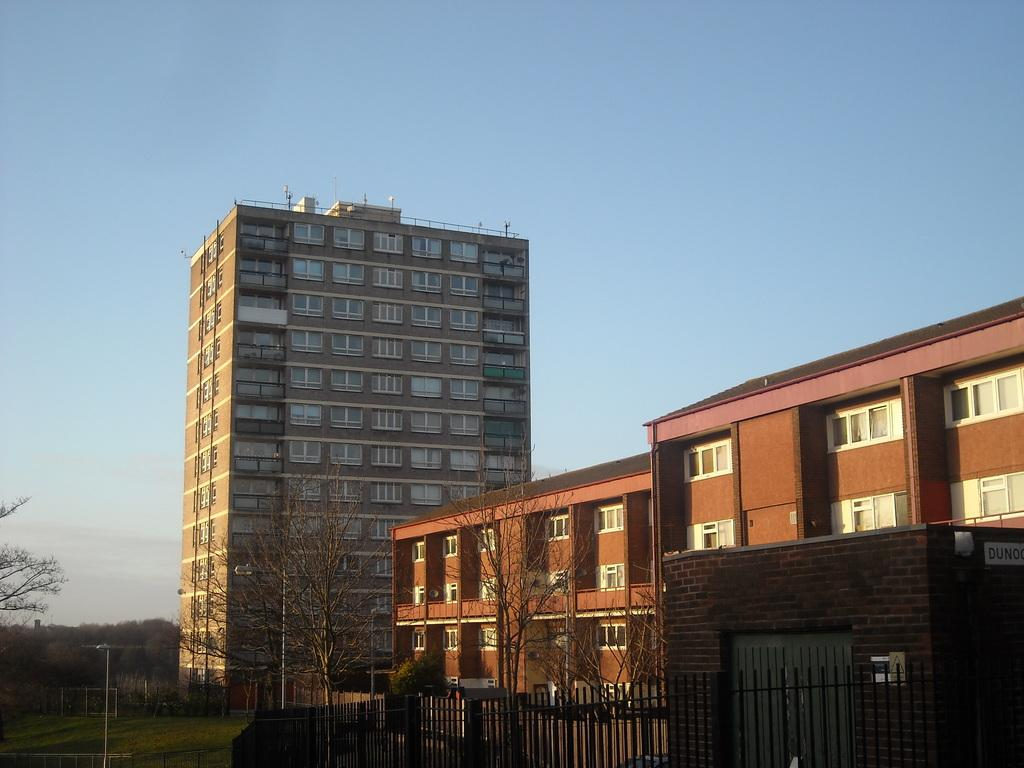What type of structures can be seen in the image? There are buildings in the image. What is located in the front of the image? Trees are visible in the front of the image. What is visible at the top of the image? The sky is visible at the top of the image. What type of barrier is present at the bottom of the image? There is a metal fencing at the bottom of the image. What color is the stocking worn by the tree in the image? There is no stocking present on the tree in the image, as trees do not wear stockings. 